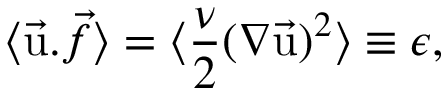Convert formula to latex. <formula><loc_0><loc_0><loc_500><loc_500>\langle \vec { u } . \vec { f } \rangle = \langle { \frac { \nu } { 2 } } ( \nabla \vec { u } ) ^ { 2 } \rangle \equiv \epsilon ,</formula> 